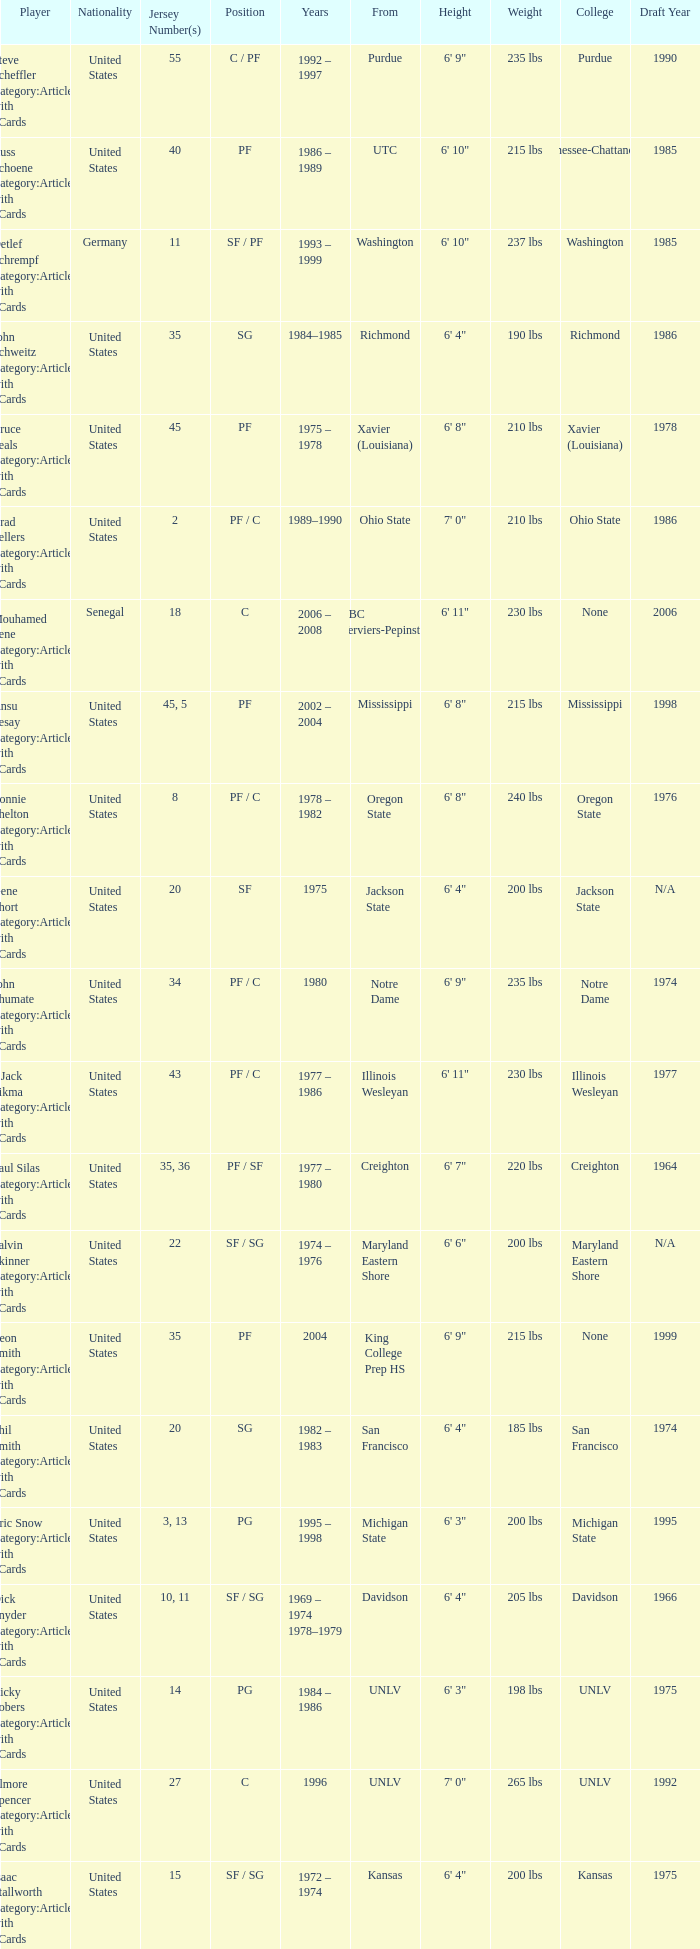What position does the player with jersey number 22 play? SF / SG. 